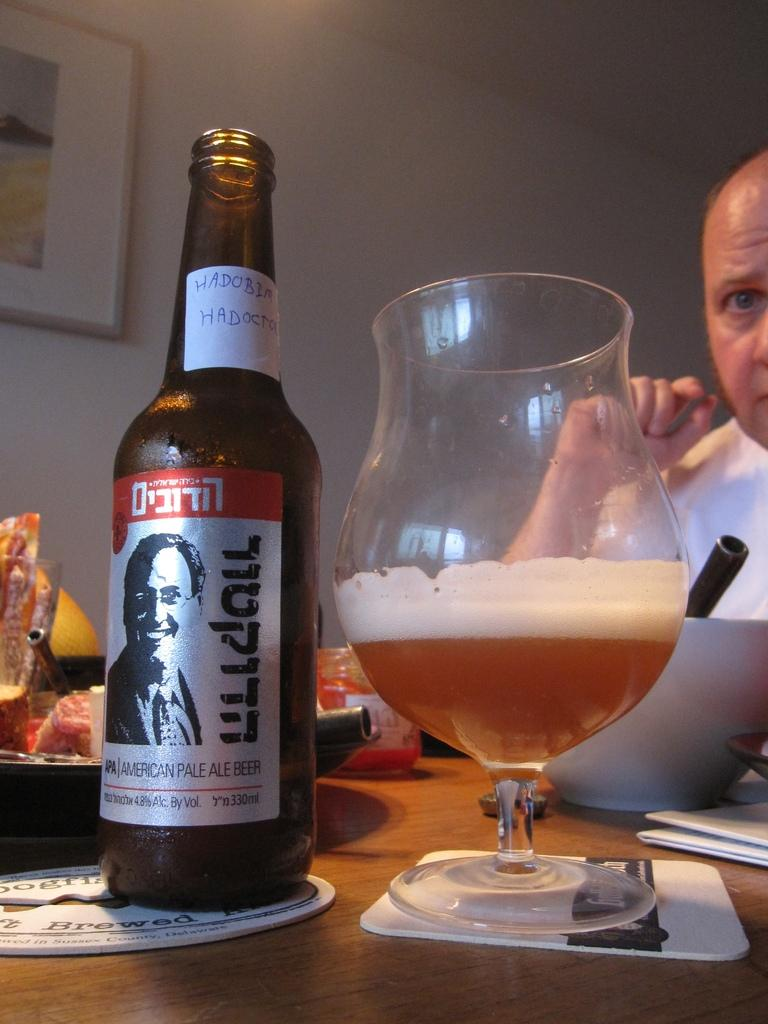<image>
Provide a brief description of the given image. A glass of American Pale Ale beer next to a amber colored bottle with silver label. 